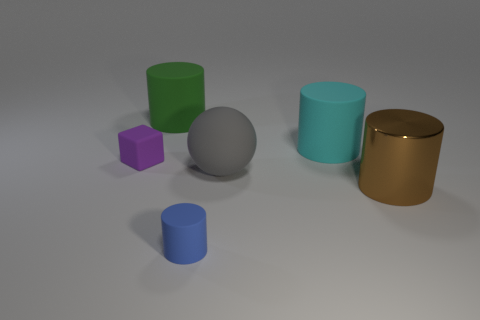Is there any other thing that is the same material as the big brown cylinder?
Offer a very short reply. No. There is a large green cylinder; what number of cylinders are on the right side of it?
Provide a succinct answer. 3. Do the tiny cylinder and the shiny thing have the same color?
Offer a terse response. No. There is a tiny blue thing that is the same material as the large green thing; what is its shape?
Give a very brief answer. Cylinder. There is a small matte thing that is left of the big green rubber cylinder; does it have the same shape as the brown metal thing?
Provide a short and direct response. No. What number of blue objects are either big balls or cylinders?
Offer a very short reply. 1. Are there an equal number of rubber things on the left side of the sphere and big green rubber cylinders right of the big green matte thing?
Ensure brevity in your answer.  No. What is the color of the matte cylinder that is to the left of the tiny thing that is to the right of the large object that is to the left of the ball?
Ensure brevity in your answer.  Green. Are there any other things that have the same color as the tiny matte cylinder?
Give a very brief answer. No. How big is the blue object to the right of the tiny purple cube?
Make the answer very short. Small. 